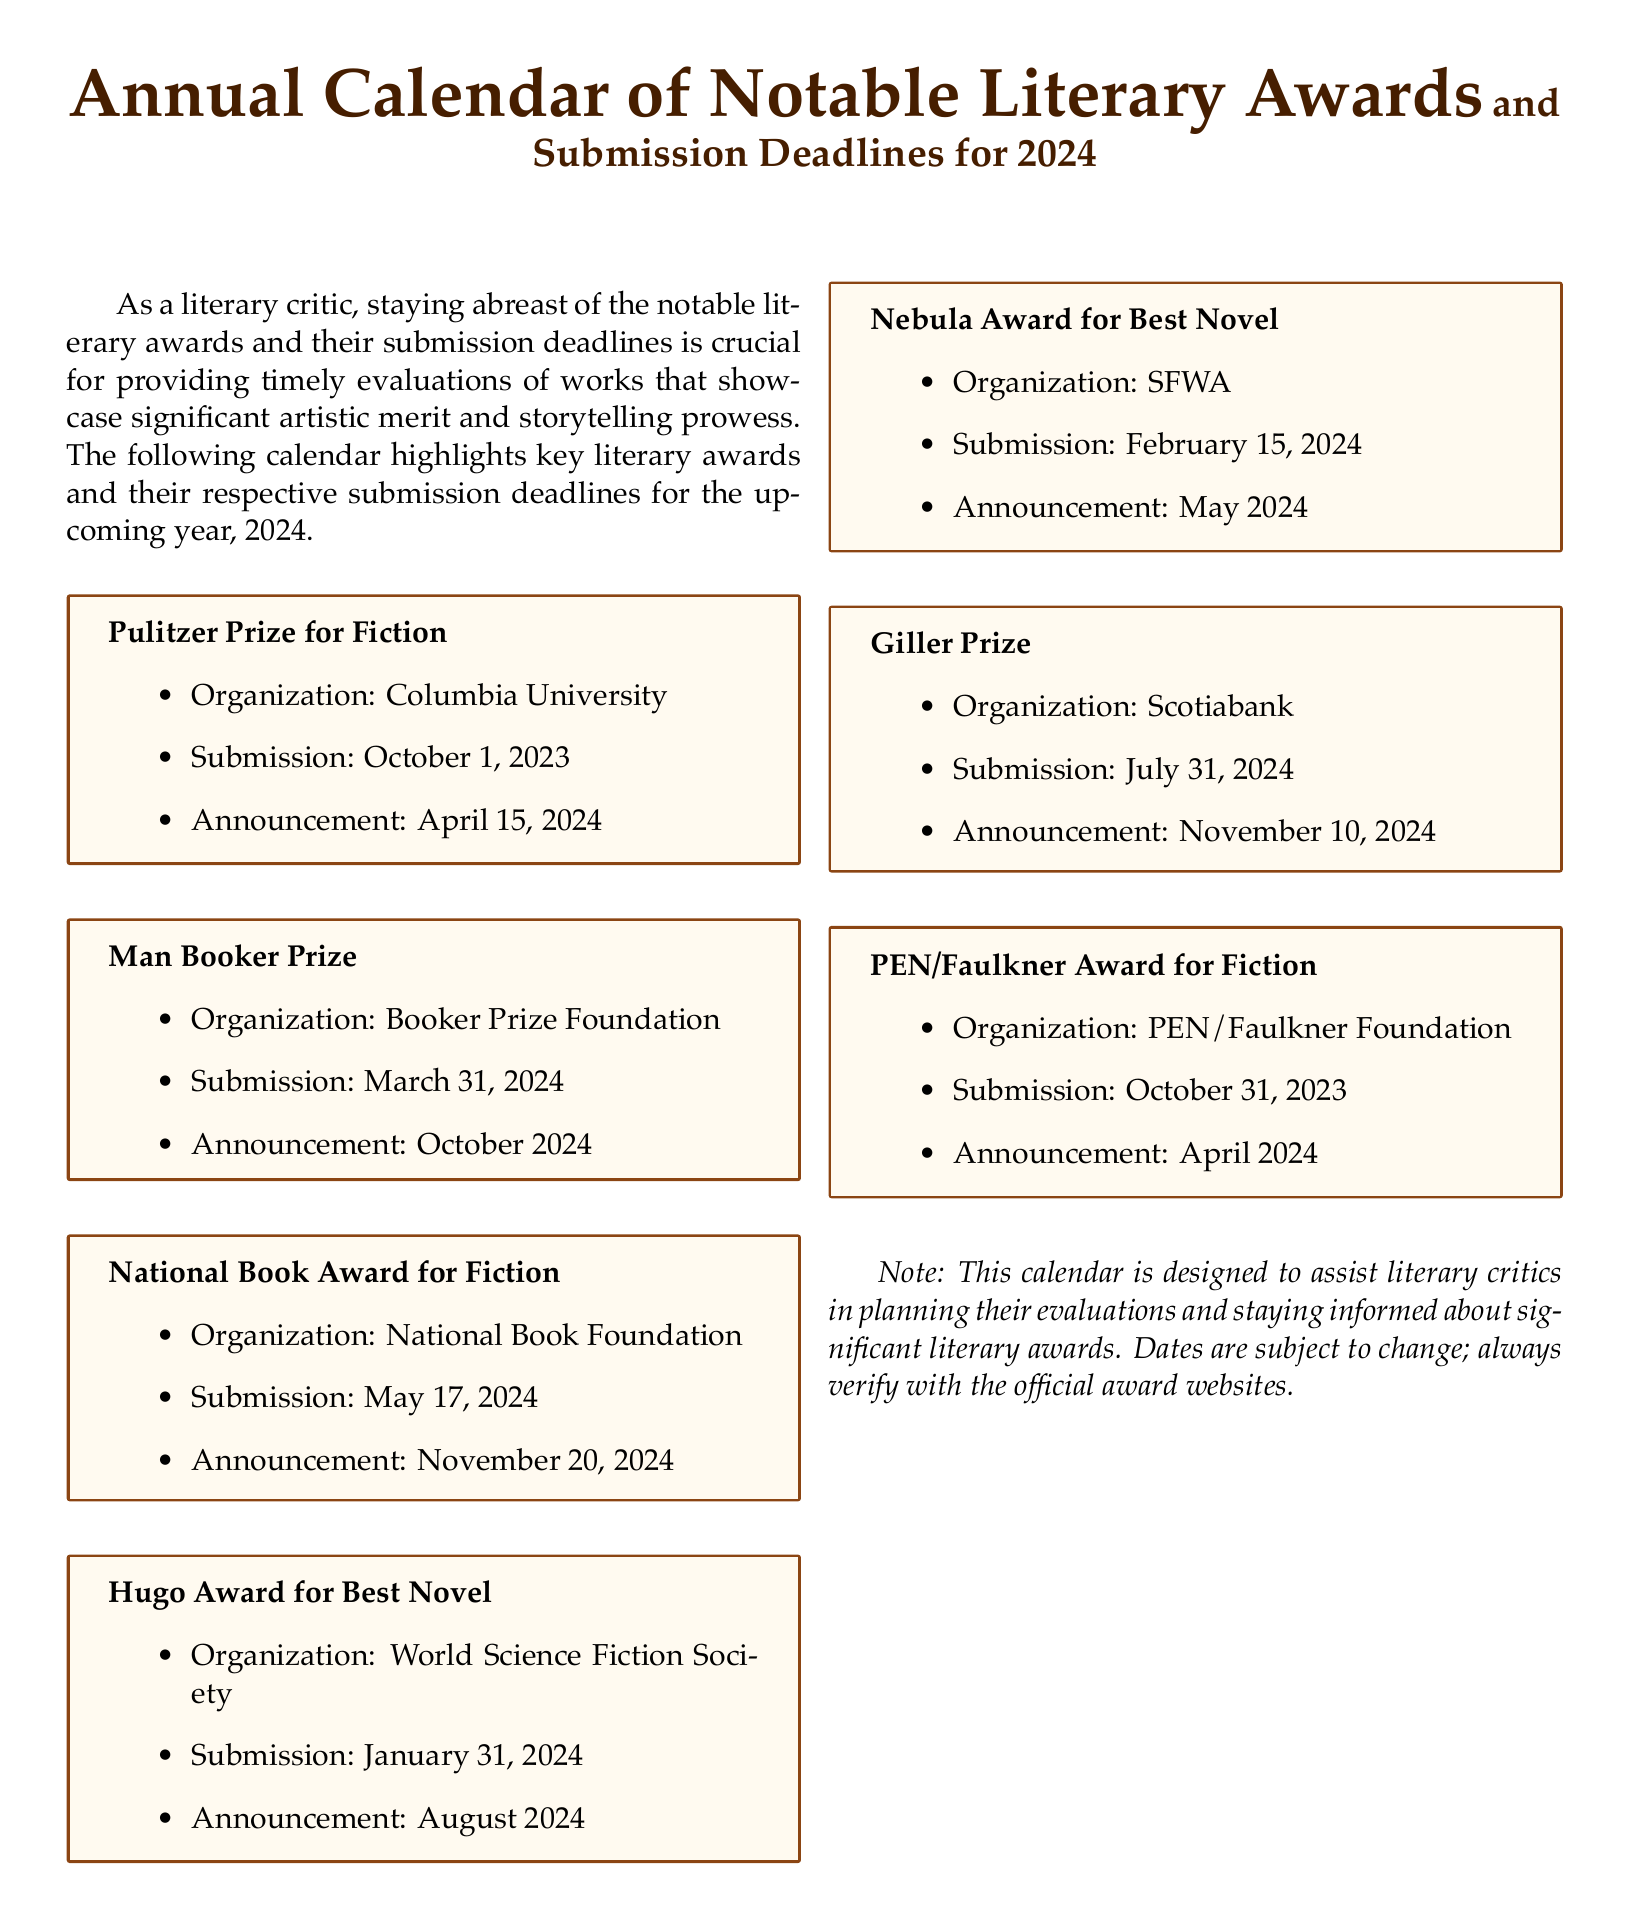What is the submission deadline for the Pulitzer Prize for Fiction? The submission deadline is specifically mentioned in the document as October 1, 2023.
Answer: October 1, 2023 Who organizes the National Book Award for Fiction? The organization responsible for this award is stated in the document as the National Book Foundation.
Answer: National Book Foundation When is the announcement for the Man Booker Prize scheduled? The document specifies that the announcement for the Man Booker Prize will be in October 2024.
Answer: October 2024 What is the submission deadline for the Hugo Award for Best Novel? The submission date for the Hugo Award for Best Novel is clearly stated as January 31, 2024.
Answer: January 31, 2024 Which award has its submission deadline last in the calendar? The document lists the Giller Prize as having the latest submission deadline mentioned, which is July 31, 2024.
Answer: Giller Prize How many awards in the calendar have a submission deadline in 2024? By counting the submission deadlines listed, one finds there are five deadlines specifically for 2024.
Answer: Five What type of literary work is eligible for the PEN/Faulkner Award? The document explicitly mentions that the award is for fiction.
Answer: Fiction When will the announcement for the Nebula Award for Best Novel occur? The specific date for the announcement is noted in the document as May 2024.
Answer: May 2024 